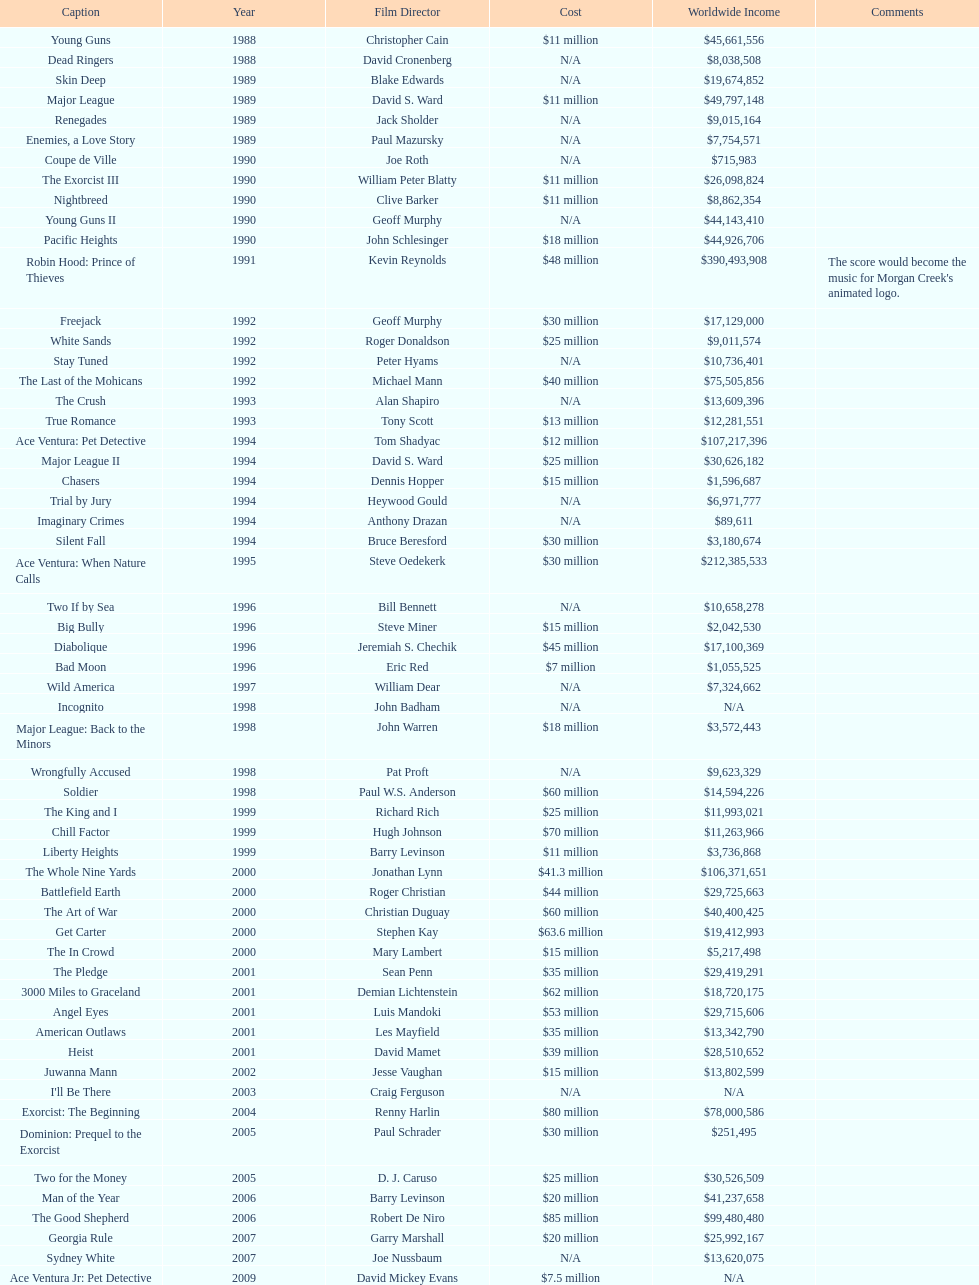Was the budget for young guns more or less than freejack's budget? Less. 